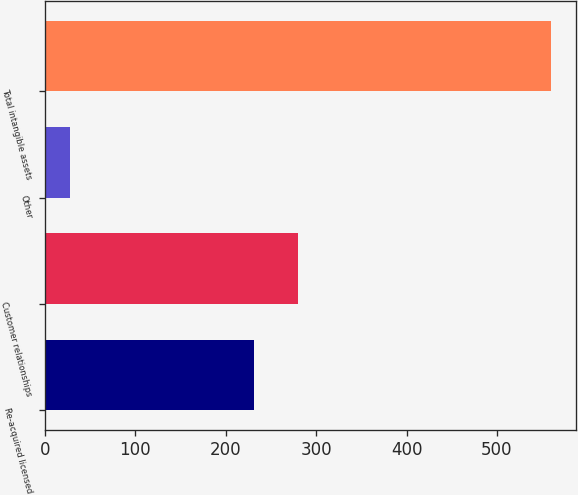Convert chart to OTSL. <chart><loc_0><loc_0><loc_500><loc_500><bar_chart><fcel>Re-acquired licensed<fcel>Customer relationships<fcel>Other<fcel>Total intangible assets<nl><fcel>231.3<fcel>280.32<fcel>27.7<fcel>559.62<nl></chart> 